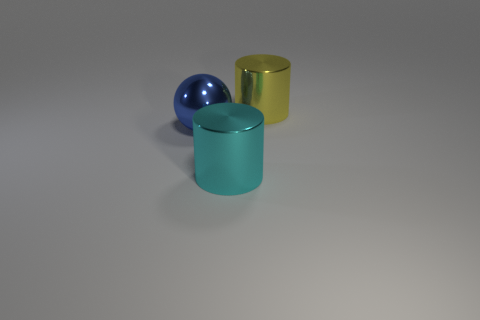Are there any big shiny cylinders that have the same color as the large sphere?
Your response must be concise. No. There is another shiny cylinder that is the same size as the yellow cylinder; what color is it?
Make the answer very short. Cyan. There is a big object that is in front of the shiny thing that is on the left side of the cyan metal object in front of the large metal ball; what is its material?
Your response must be concise. Metal. Does the large metallic ball have the same color as the metallic object that is behind the large sphere?
Give a very brief answer. No. How many objects are big metallic cylinders in front of the large yellow cylinder or large cylinders that are in front of the large ball?
Your answer should be very brief. 1. The large cyan metal thing that is left of the thing that is behind the blue shiny sphere is what shape?
Provide a succinct answer. Cylinder. Is there a block made of the same material as the big cyan cylinder?
Provide a succinct answer. No. What color is the other shiny thing that is the same shape as the large yellow metal object?
Your answer should be compact. Cyan. Are there fewer metallic balls right of the large yellow object than cyan metallic cylinders that are left of the metallic ball?
Provide a short and direct response. No. What number of other things are the same shape as the big blue metal object?
Your answer should be compact. 0. 